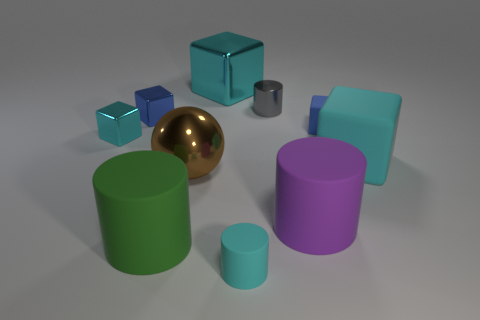There is a tiny rubber thing that is the same color as the big metallic cube; what is its shape?
Provide a short and direct response. Cylinder. What is the shape of the gray thing that is the same size as the cyan cylinder?
Offer a very short reply. Cylinder. What is the material of the object that is the same color as the small rubber cube?
Give a very brief answer. Metal. Are there any blue metal objects behind the cyan matte cylinder?
Provide a short and direct response. Yes. Is there a large cyan matte thing that has the same shape as the blue shiny object?
Your answer should be very brief. Yes. Does the large cyan object that is behind the cyan rubber block have the same shape as the cyan metallic thing in front of the gray metallic cylinder?
Your response must be concise. Yes. Is there a blue metal cylinder of the same size as the brown ball?
Provide a short and direct response. No. Are there the same number of big shiny things that are to the right of the large purple cylinder and small blue metal blocks behind the small gray shiny cylinder?
Your answer should be compact. Yes. Is the gray cylinder that is behind the small cyan metallic block made of the same material as the large cyan cube that is to the right of the large purple cylinder?
Your answer should be compact. No. What material is the tiny gray thing?
Keep it short and to the point. Metal. 